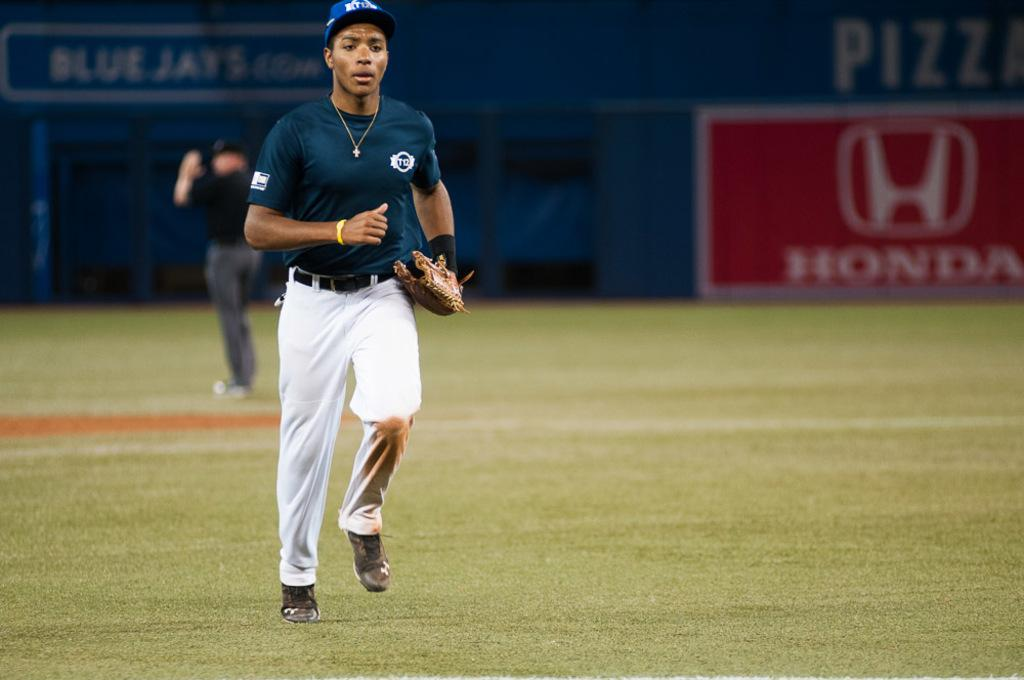<image>
Offer a succinct explanation of the picture presented. A baseball player is on the field in front of a Honda sign. 